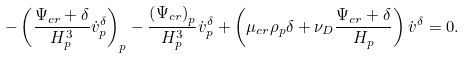Convert formula to latex. <formula><loc_0><loc_0><loc_500><loc_500>- \left ( \frac { \Psi _ { c r } + \delta } { H _ { p } ^ { 3 } } \dot { v } _ { p } ^ { \delta } \right ) _ { p } - \frac { \left ( \Psi _ { c r } \right ) _ { p } } { H _ { p } ^ { 3 } } \dot { v } _ { p } ^ { \delta } + \left ( \mu _ { c r } \rho _ { p } \delta + \nu _ { D } \frac { \Psi _ { c r } + \delta } { H _ { p } } \right ) \dot { v } ^ { \delta } = 0 .</formula> 